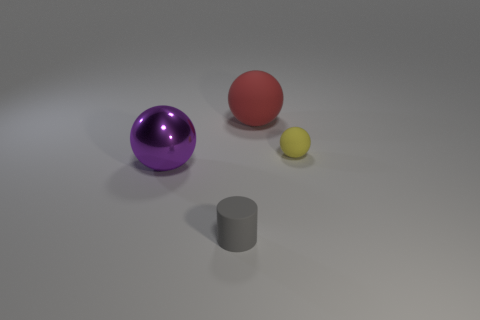Are there any other things that have the same material as the big purple object?
Offer a very short reply. No. What size is the thing that is both on the left side of the large red ball and behind the gray rubber cylinder?
Your answer should be compact. Large. What is the material of the purple object that is the same size as the red rubber thing?
Offer a very short reply. Metal. What number of red matte things are on the left side of the gray cylinder that is in front of the small rubber thing that is right of the cylinder?
Make the answer very short. 0. The sphere that is both on the left side of the tiny rubber sphere and behind the big purple metallic ball is what color?
Give a very brief answer. Red. How many other cylinders have the same size as the cylinder?
Keep it short and to the point. 0. There is a large thing that is left of the object in front of the large purple metallic thing; what is its shape?
Your answer should be very brief. Sphere. What shape is the small thing right of the tiny rubber thing that is in front of the big thing that is left of the gray rubber cylinder?
Your response must be concise. Sphere. How many big red rubber things have the same shape as the big purple shiny thing?
Your answer should be compact. 1. How many small balls are left of the thing to the right of the red matte thing?
Ensure brevity in your answer.  0. 